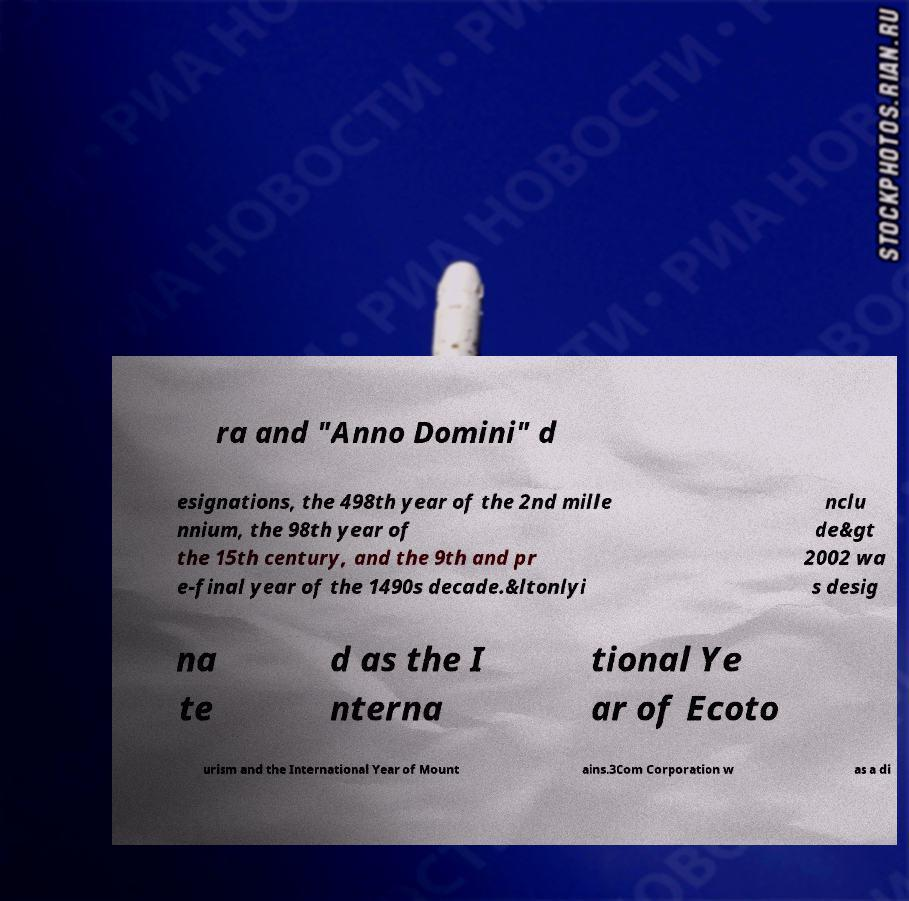There's text embedded in this image that I need extracted. Can you transcribe it verbatim? ra and "Anno Domini" d esignations, the 498th year of the 2nd mille nnium, the 98th year of the 15th century, and the 9th and pr e-final year of the 1490s decade.&ltonlyi nclu de&gt 2002 wa s desig na te d as the I nterna tional Ye ar of Ecoto urism and the International Year of Mount ains.3Com Corporation w as a di 